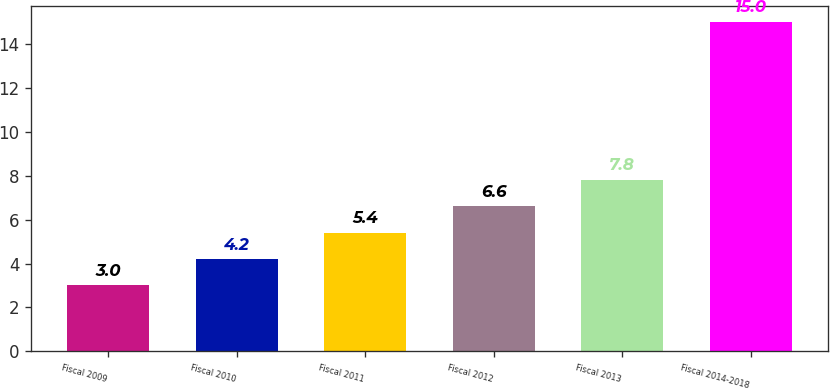Convert chart to OTSL. <chart><loc_0><loc_0><loc_500><loc_500><bar_chart><fcel>Fiscal 2009<fcel>Fiscal 2010<fcel>Fiscal 2011<fcel>Fiscal 2012<fcel>Fiscal 2013<fcel>Fiscal 2014-2018<nl><fcel>3<fcel>4.2<fcel>5.4<fcel>6.6<fcel>7.8<fcel>15<nl></chart> 